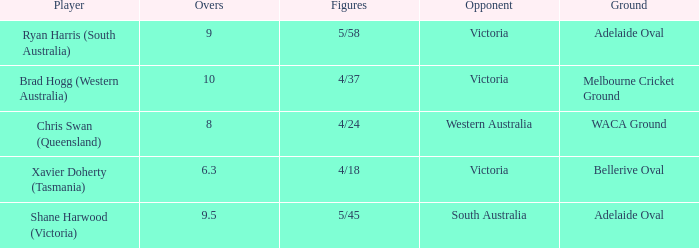What did Xavier Doherty (Tasmania) set as his highest Overs? 6.3. 